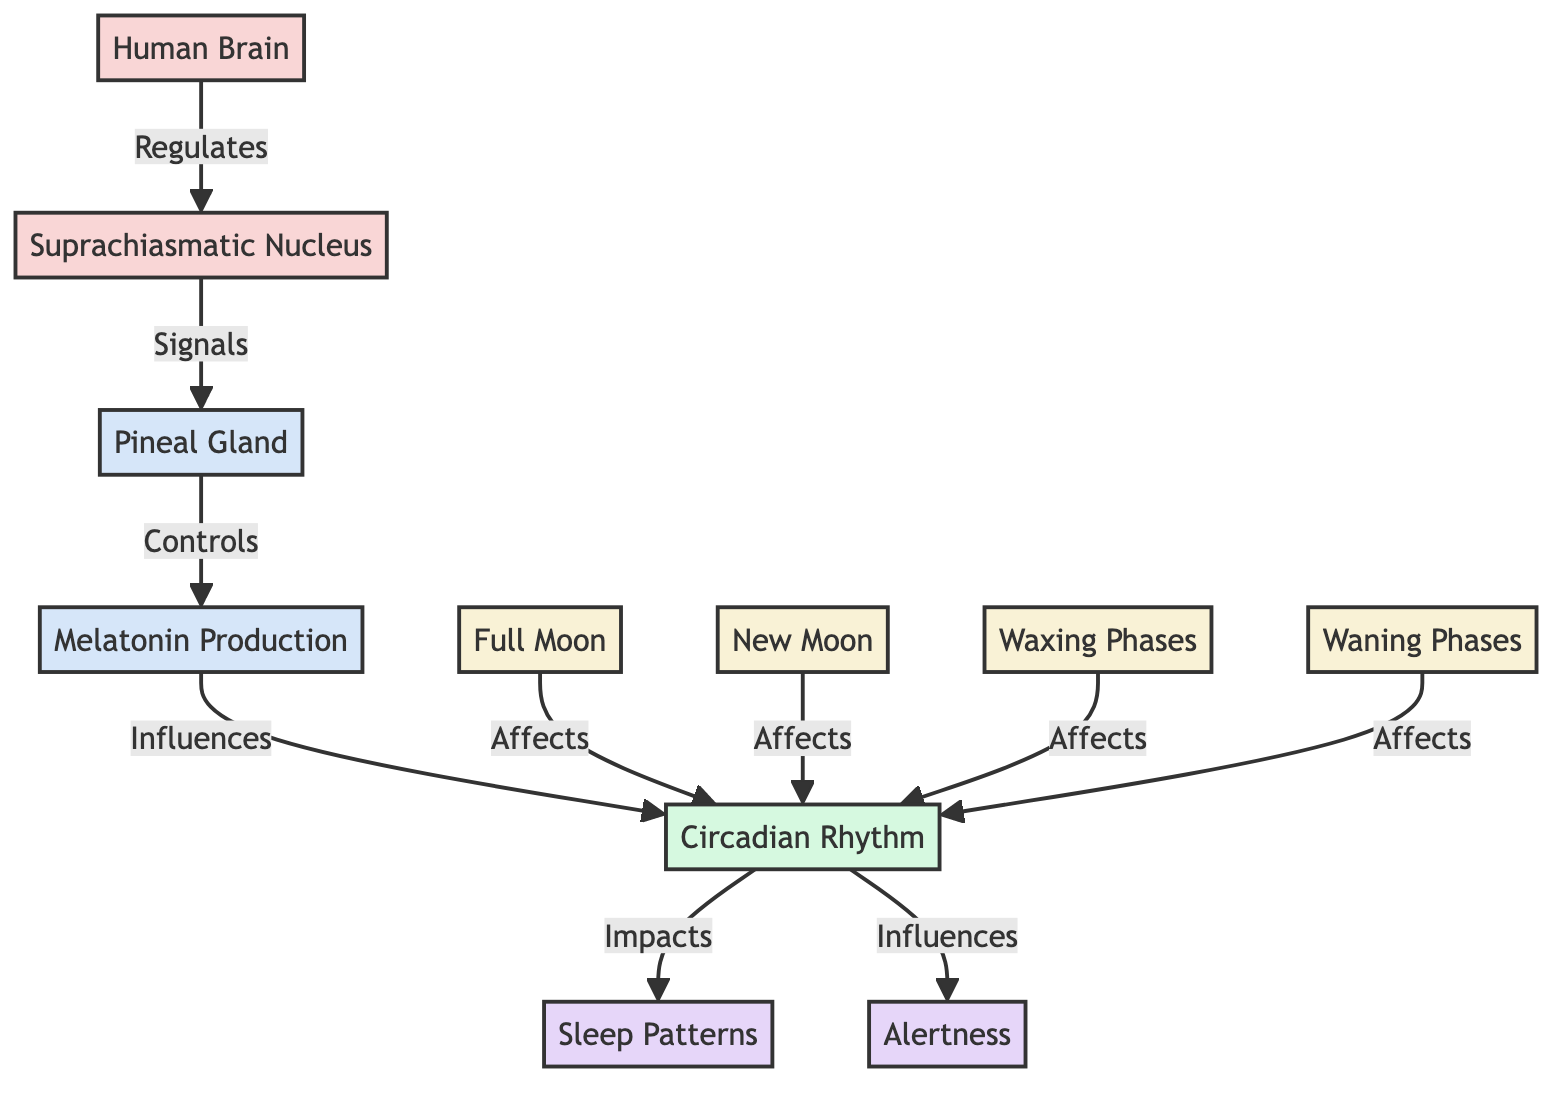What does the Suprachiasmatic Nucleus regulate? The diagram indicates that the Suprachiasmatic Nucleus regulates the Human Brain. Therefore, the relationship shows that it is under the control of the Human Brain.
Answer: Human Brain How many lunar phases are shown in the diagram? The diagram displays four lunar phases: Full Moon, New Moon, Waxing Phases, and Waning Phases. Counting these nodes gives a total of four.
Answer: 4 What produces melatonin? According to the diagram, the Pineal Gland is responsible for controlling the production of melatonin. This is the direct link outlined in the flowchart.
Answer: Pineal Gland Which factor influences the Circadian Rhythm along with the Pineal Gland? Both the Full Moon and New Moon influence the Circadian Rhythm, as indicated by the connections from these lunar phases to the Circadian Rhythm node.
Answer: Full Moon, New Moon What impacts sleep patterns? The diagram shows that Circadian Rhythm impacts Sleep Patterns, establishing a direct relationship between these two nodes.
Answer: Circadian Rhythm Which gland is indicated in the diagram? The Pineal Gland is specifically mentioned in the diagram as a component involved in melatonin production, making it a highlighted gland in this context.
Answer: Pineal Gland How does the Circadian Rhythm relate to alertness? From the diagram, it is clear that the Circadian Rhythm influences alertness, signifying a direct correlation between these two factors.
Answer: Influences What is the main effect of the Circadian Rhythm according to the diagram? The main effects of Circadian Rhythm shown are Sleep Patterns and Alertness. This is a summarization of its outcomes based on the diagram's structure.
Answer: Sleep Patterns, Alertness Which node indicates that lunar phases affect Circadian Rhythm? The diagram links multiple nodes (Full Moon, New Moon, Waxing Phases, Waning Phases) directly to the Circadian Rhythm, highlighting that lunar phases affect this rhythm.
Answer: Full Moon, New Moon, Waxing Phases, Waning Phases 